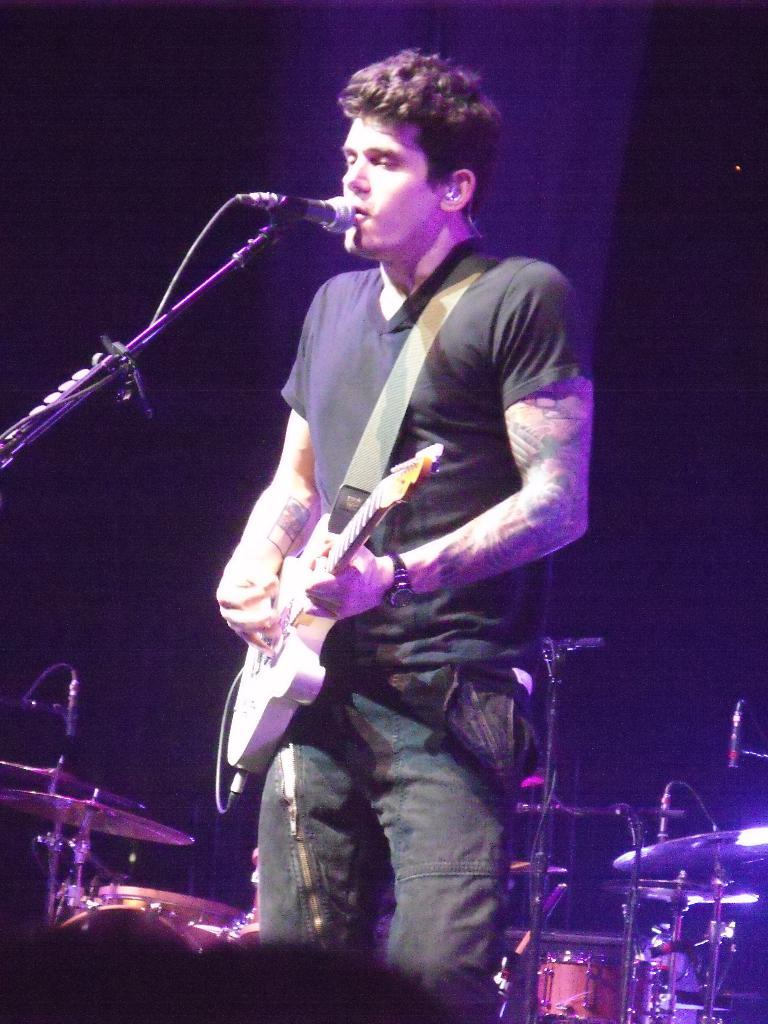What is the person in the image doing? The person is holding a guitar in his left hand and playing it with his right hand. What object is in front of the person? There is a microphone in front of the person. What type of cork can be seen on the guitar strings in the image? There is no cork present on the guitar strings in the image. Can you see any pets interacting with the person in the image? There are no pets visible in the image. 